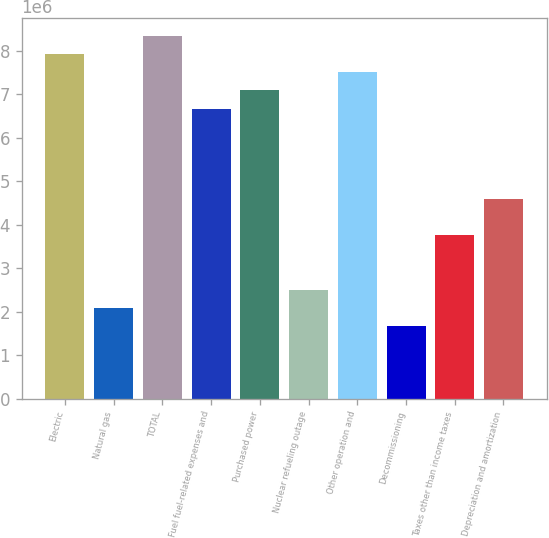<chart> <loc_0><loc_0><loc_500><loc_500><bar_chart><fcel>Electric<fcel>Natural gas<fcel>TOTAL<fcel>Fuel fuel-related expenses and<fcel>Purchased power<fcel>Nuclear refueling outage<fcel>Other operation and<fcel>Decommissioning<fcel>Taxes other than income taxes<fcel>Depreciation and amortization<nl><fcel>7.92595e+06<fcel>2.09432e+06<fcel>8.3425e+06<fcel>6.67632e+06<fcel>7.09286e+06<fcel>2.51087e+06<fcel>7.50941e+06<fcel>1.67778e+06<fcel>3.7605e+06<fcel>4.59359e+06<nl></chart> 